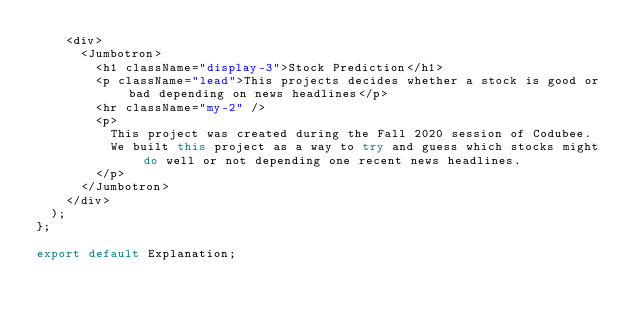Convert code to text. <code><loc_0><loc_0><loc_500><loc_500><_JavaScript_>    <div>
      <Jumbotron>
        <h1 className="display-3">Stock Prediction</h1>
        <p className="lead">This projects decides whether a stock is good or bad depending on news headlines</p>
        <hr className="my-2" />
        <p>
          This project was created during the Fall 2020 session of Codubee.
          We built this project as a way to try and guess which stocks might do well or not depending one recent news headlines.
        </p>
      </Jumbotron>
    </div>
  );
};

export default Explanation;</code> 